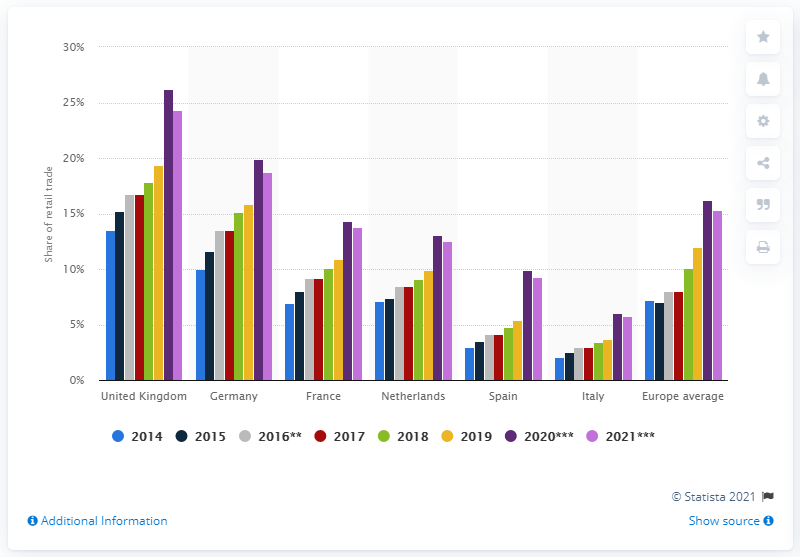Identify some key points in this picture. The United Kingdom led the country comparison in each year. 